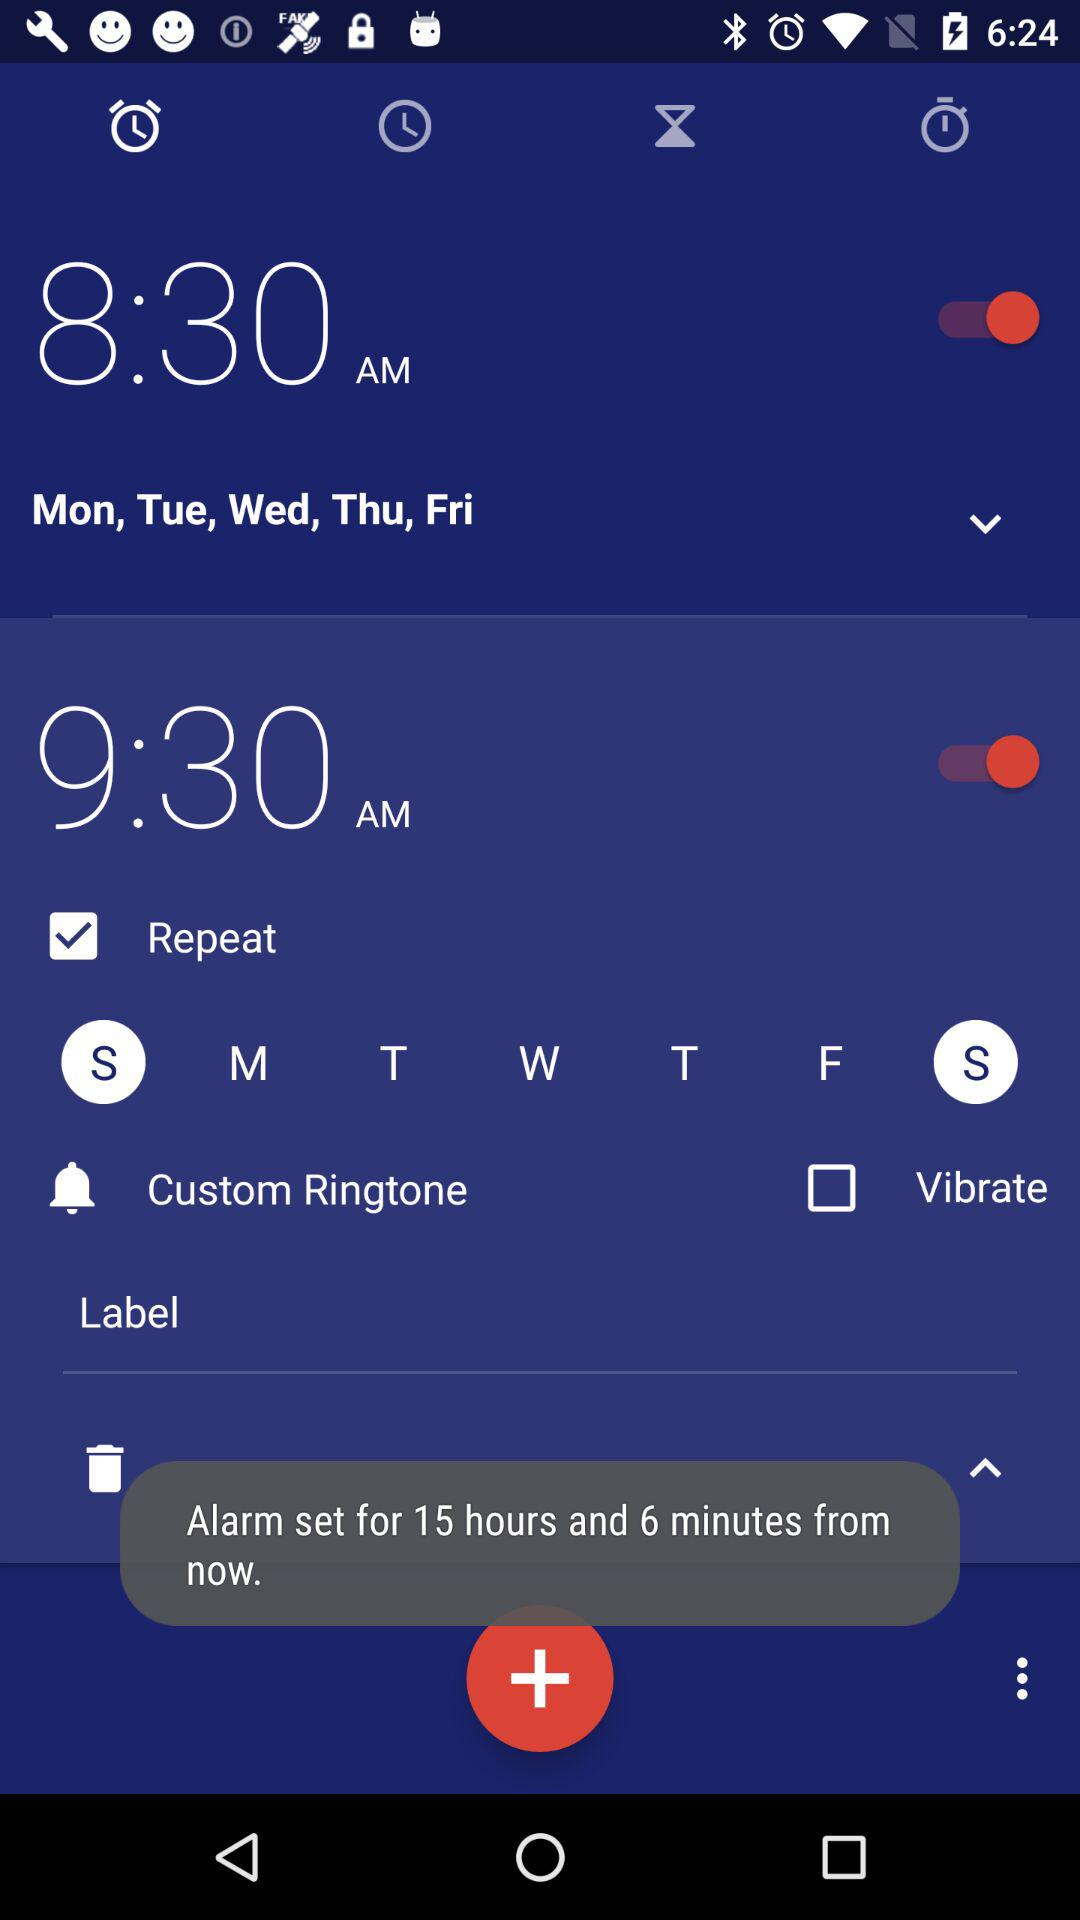What is the selected alarm time from Monday to Friday? The selected alarm time is 8:30 AM. 